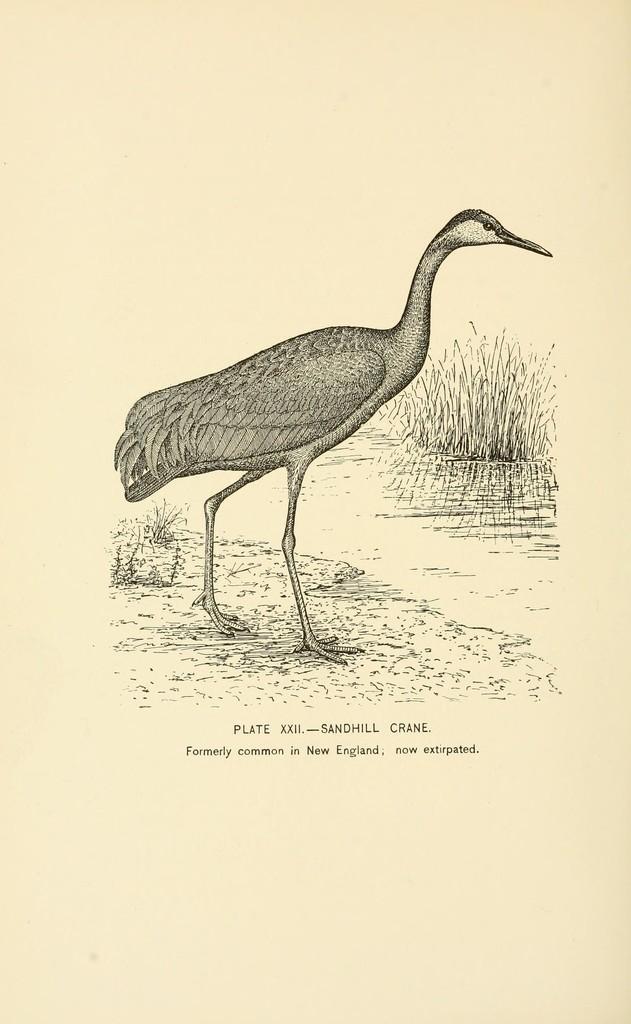Please provide a concise description of this image. In the image there is a crane standing on the ground. In front of the crane there is a grass. To the bottom of the crane there is something written on it. 